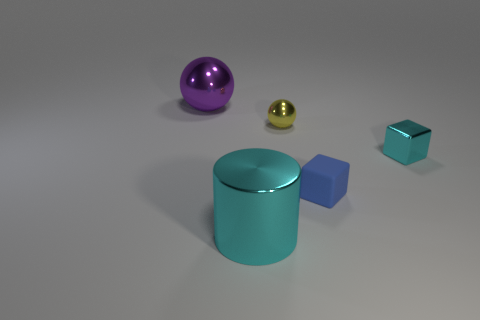Add 1 cyan rubber balls. How many objects exist? 6 Subtract all spheres. How many objects are left? 3 Add 5 large cyan metal things. How many large cyan metal things are left? 6 Add 4 large shiny cylinders. How many large shiny cylinders exist? 5 Subtract 0 red balls. How many objects are left? 5 Subtract all large purple metal things. Subtract all shiny balls. How many objects are left? 2 